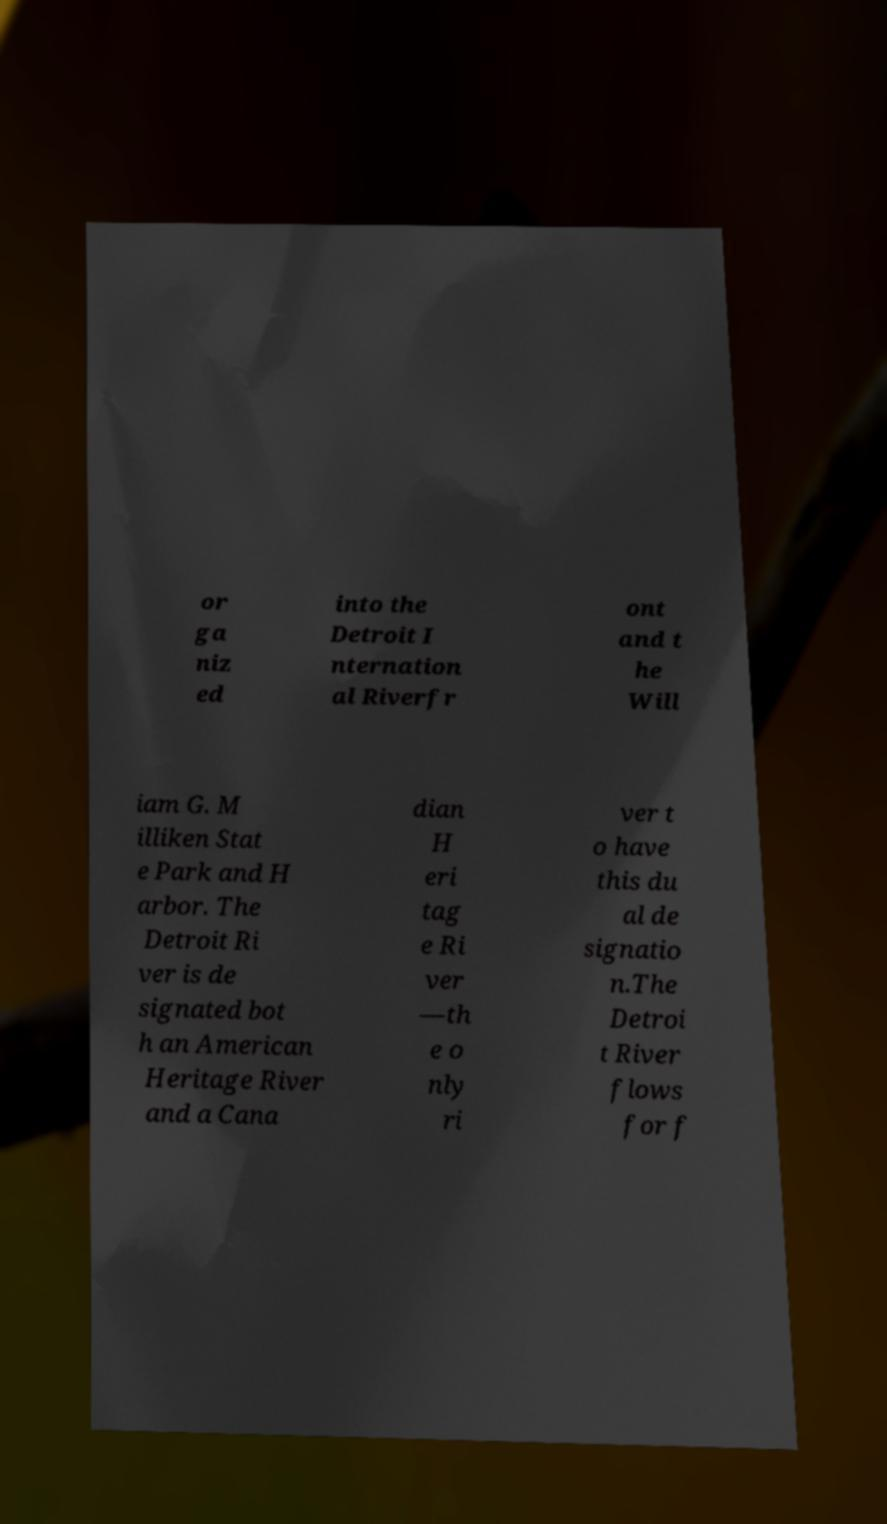There's text embedded in this image that I need extracted. Can you transcribe it verbatim? or ga niz ed into the Detroit I nternation al Riverfr ont and t he Will iam G. M illiken Stat e Park and H arbor. The Detroit Ri ver is de signated bot h an American Heritage River and a Cana dian H eri tag e Ri ver —th e o nly ri ver t o have this du al de signatio n.The Detroi t River flows for f 